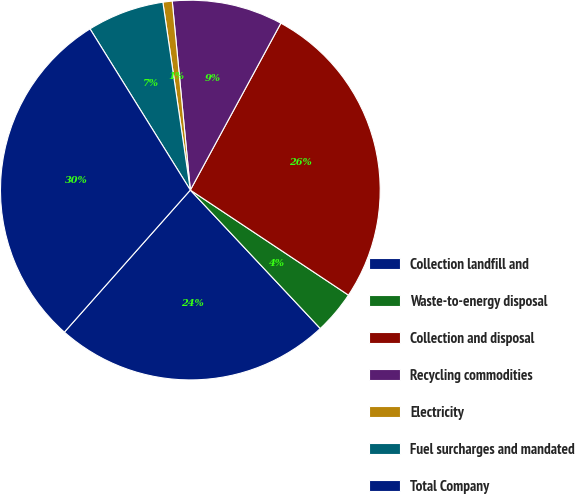Convert chart to OTSL. <chart><loc_0><loc_0><loc_500><loc_500><pie_chart><fcel>Collection landfill and<fcel>Waste-to-energy disposal<fcel>Collection and disposal<fcel>Recycling commodities<fcel>Electricity<fcel>Fuel surcharges and mandated<fcel>Total Company<nl><fcel>23.54%<fcel>3.67%<fcel>26.42%<fcel>9.43%<fcel>0.79%<fcel>6.55%<fcel>29.59%<nl></chart> 